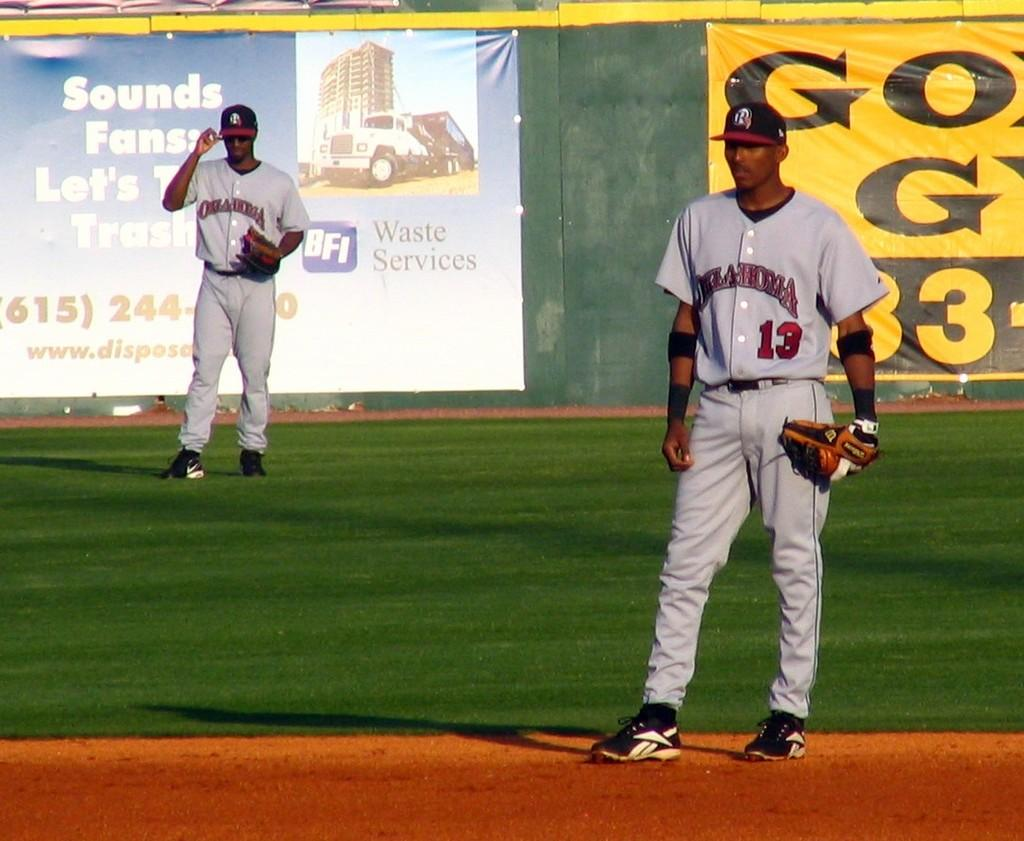<image>
Write a terse but informative summary of the picture. Two baseball players from the team Oklahoma on the field of play 